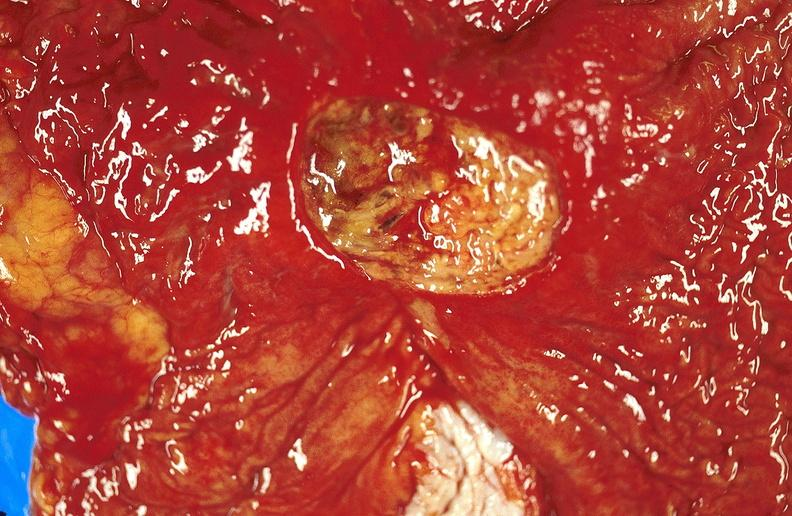s gastrointestinal present?
Answer the question using a single word or phrase. Yes 